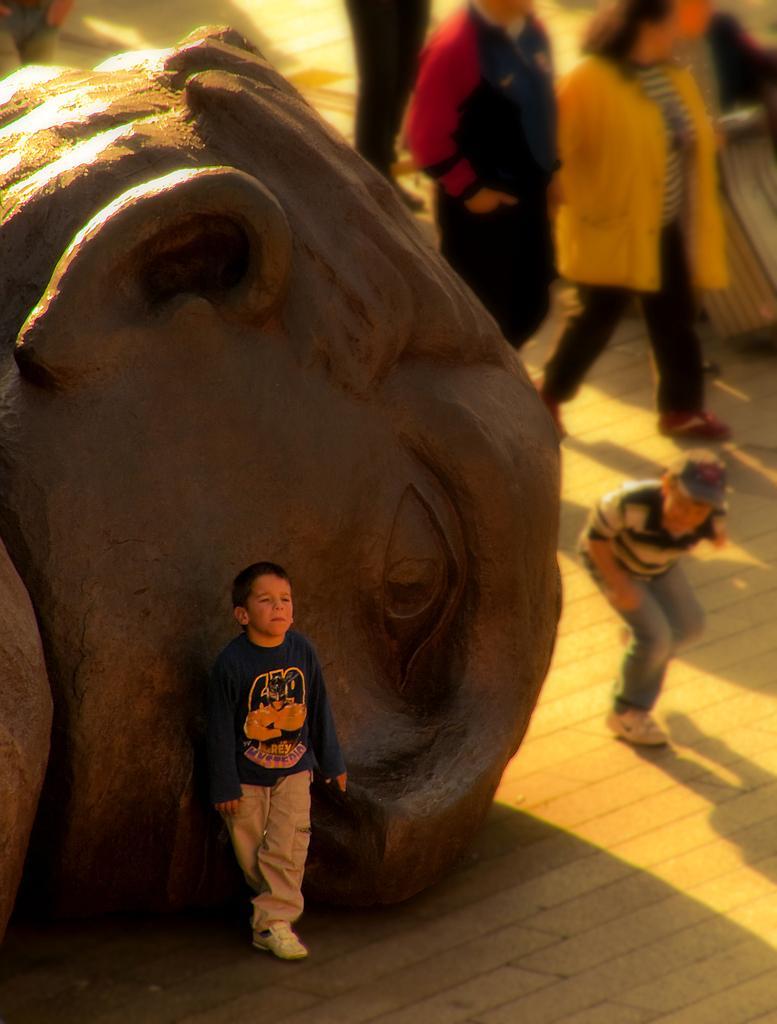Can you describe this image briefly? In this image we can see a child wearing blue color T-shirt and shoes is standing on the ground near the statue. This part of the image is blurred, where we can see a few people are walking on the floor. 